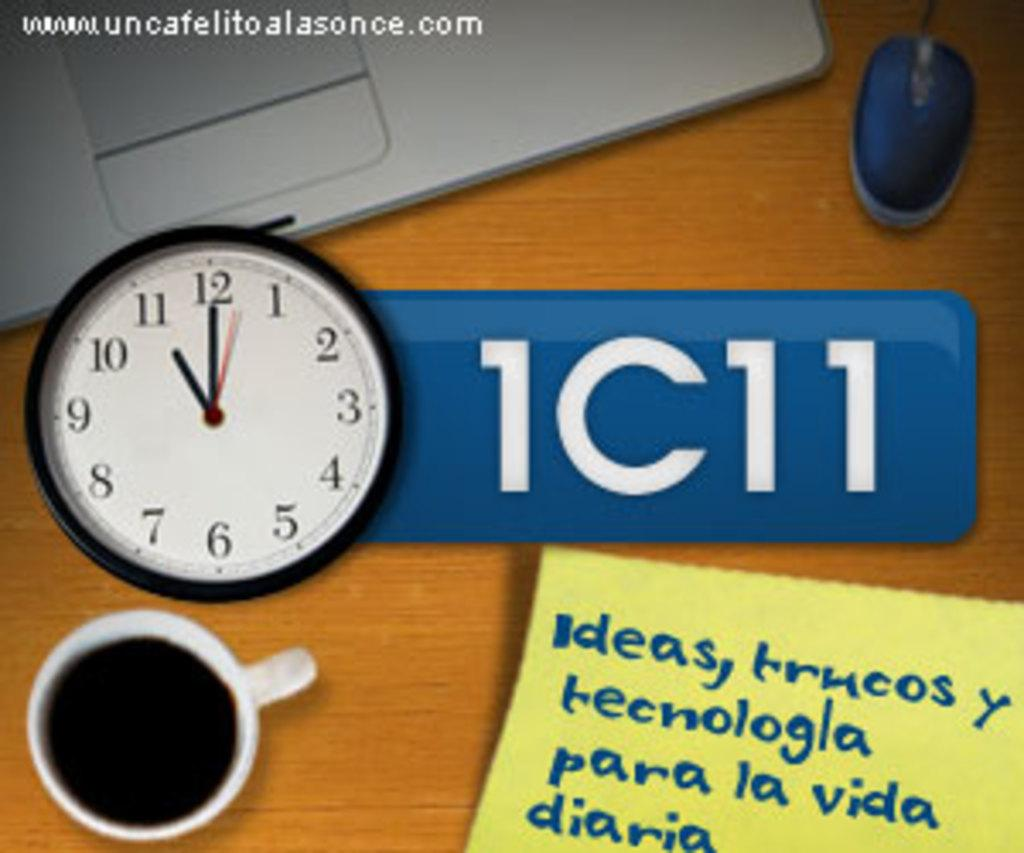Provide a one-sentence caption for the provided image. A person's desk that has a clock, a cup of coffee, and notes to remind them of ideas is set up. 